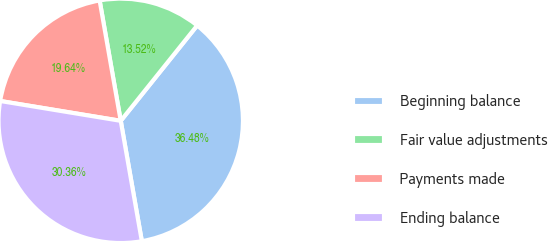Convert chart. <chart><loc_0><loc_0><loc_500><loc_500><pie_chart><fcel>Beginning balance<fcel>Fair value adjustments<fcel>Payments made<fcel>Ending balance<nl><fcel>36.48%<fcel>13.52%<fcel>19.64%<fcel>30.36%<nl></chart> 